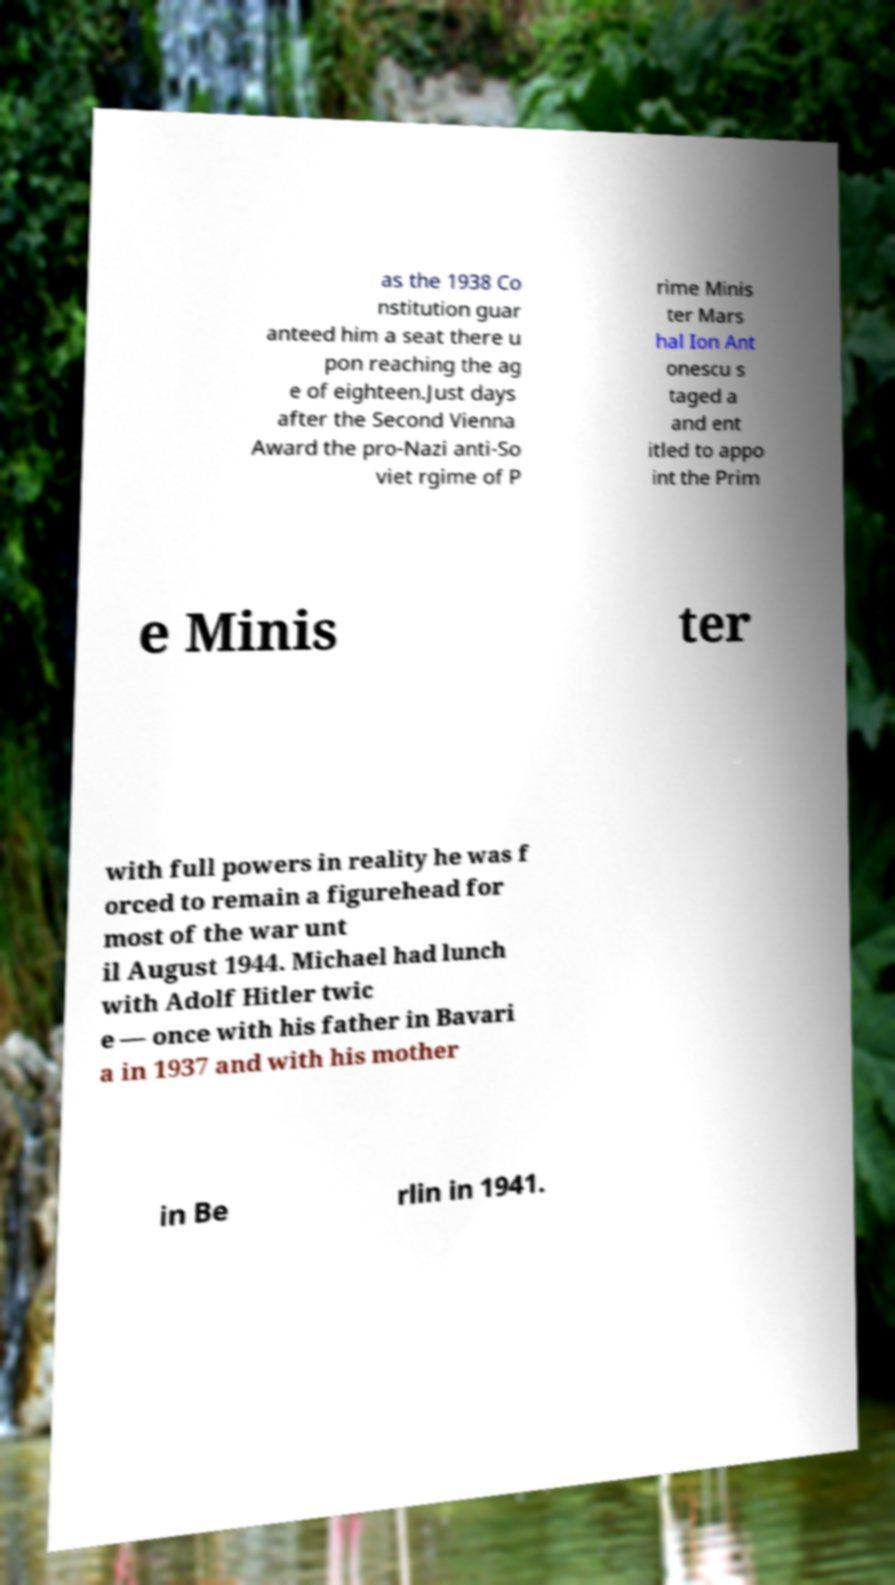I need the written content from this picture converted into text. Can you do that? as the 1938 Co nstitution guar anteed him a seat there u pon reaching the ag e of eighteen.Just days after the Second Vienna Award the pro-Nazi anti-So viet rgime of P rime Minis ter Mars hal Ion Ant onescu s taged a and ent itled to appo int the Prim e Minis ter with full powers in reality he was f orced to remain a figurehead for most of the war unt il August 1944. Michael had lunch with Adolf Hitler twic e — once with his father in Bavari a in 1937 and with his mother in Be rlin in 1941. 